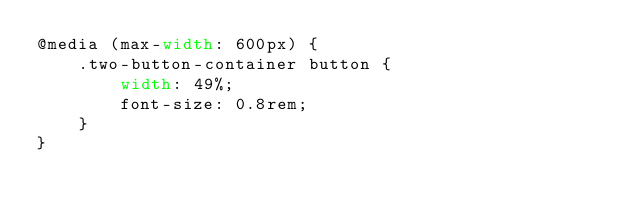Convert code to text. <code><loc_0><loc_0><loc_500><loc_500><_CSS_>@media (max-width: 600px) {
    .two-button-container button {
        width: 49%;
        font-size: 0.8rem;
    }
}
</code> 